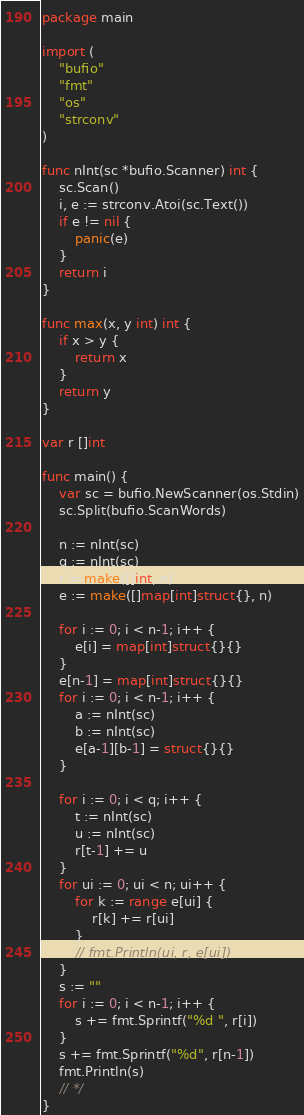Convert code to text. <code><loc_0><loc_0><loc_500><loc_500><_Go_>package main

import (
	"bufio"
	"fmt"
	"os"
	"strconv"
)

func nInt(sc *bufio.Scanner) int {
	sc.Scan()
	i, e := strconv.Atoi(sc.Text())
	if e != nil {
		panic(e)
	}
	return i
}

func max(x, y int) int {
	if x > y {
		return x
	}
	return y
}

var r []int

func main() {
	var sc = bufio.NewScanner(os.Stdin)
	sc.Split(bufio.ScanWords)

	n := nInt(sc)
	q := nInt(sc)
	r = make([]int, n)
	e := make([]map[int]struct{}, n)

	for i := 0; i < n-1; i++ {
		e[i] = map[int]struct{}{}
	}
	e[n-1] = map[int]struct{}{}
	for i := 0; i < n-1; i++ {
		a := nInt(sc)
		b := nInt(sc)
		e[a-1][b-1] = struct{}{}
	}

	for i := 0; i < q; i++ {
		t := nInt(sc)
		u := nInt(sc)
		r[t-1] += u
	}
	for ui := 0; ui < n; ui++ {
		for k := range e[ui] {
			r[k] += r[ui]
		}
		// fmt.Println(ui, r, e[ui])
	}
	s := ""
	for i := 0; i < n-1; i++ {
		s += fmt.Sprintf("%d ", r[i])
	}
	s += fmt.Sprintf("%d", r[n-1])
	fmt.Println(s)
	// */
}
</code> 